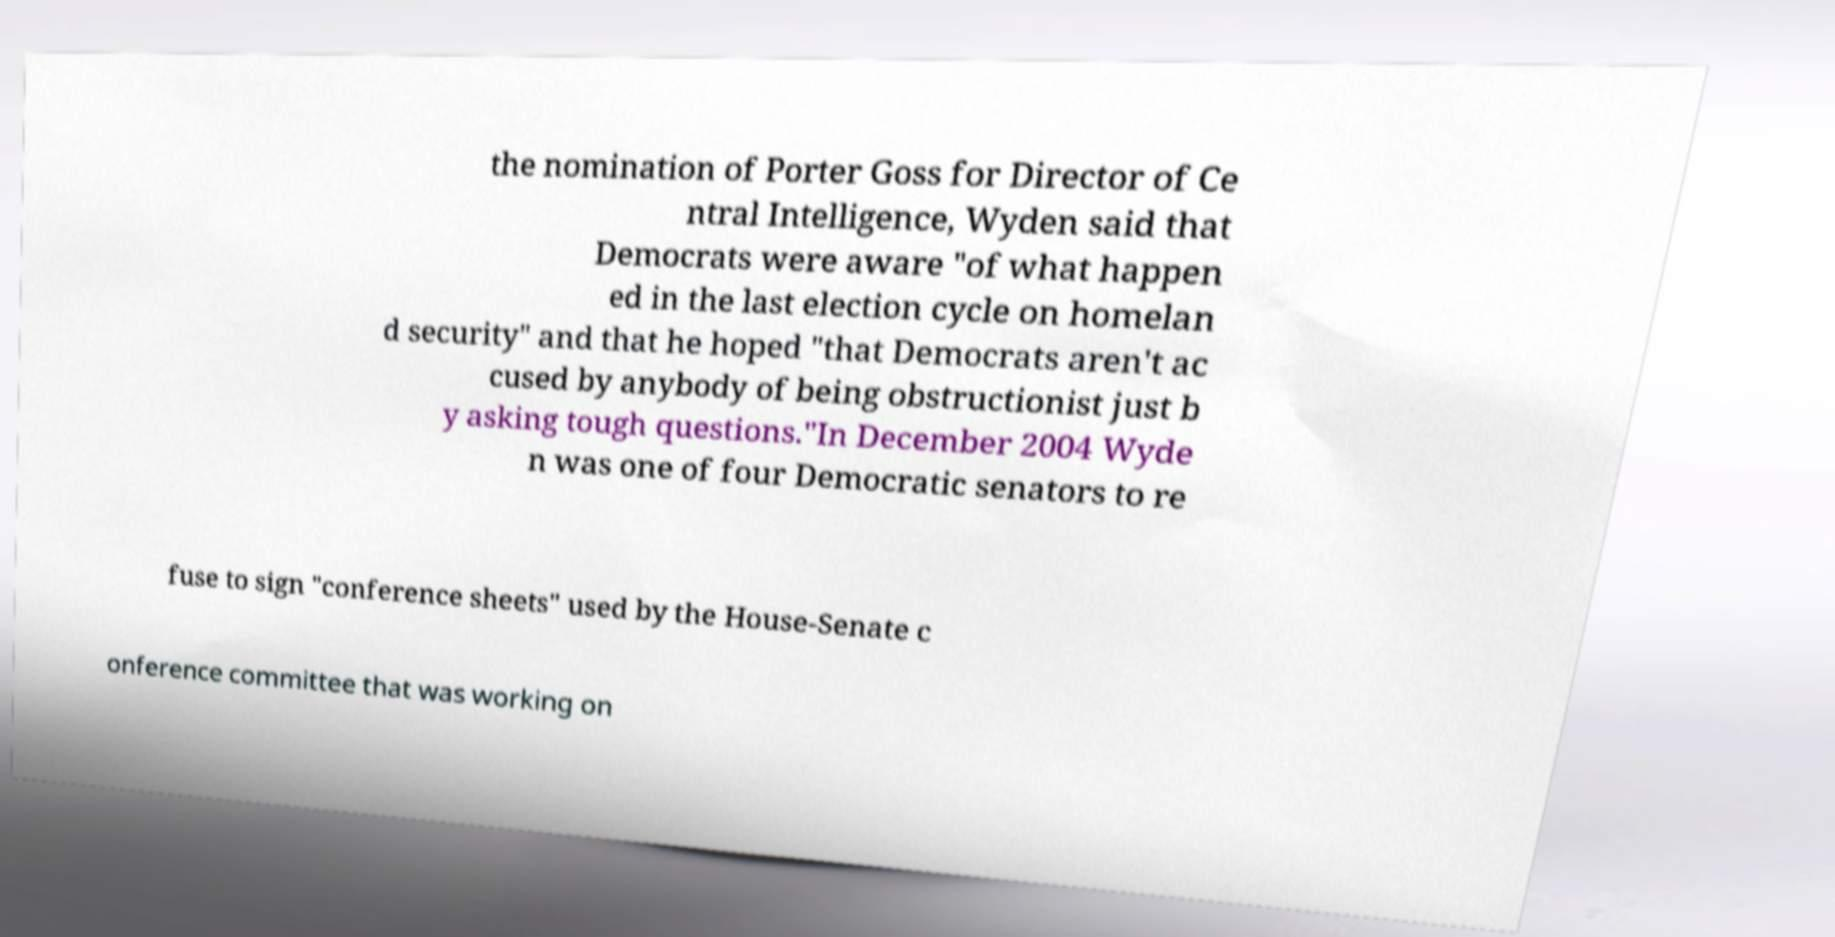What messages or text are displayed in this image? I need them in a readable, typed format. the nomination of Porter Goss for Director of Ce ntral Intelligence, Wyden said that Democrats were aware "of what happen ed in the last election cycle on homelan d security" and that he hoped "that Democrats aren't ac cused by anybody of being obstructionist just b y asking tough questions."In December 2004 Wyde n was one of four Democratic senators to re fuse to sign "conference sheets" used by the House-Senate c onference committee that was working on 